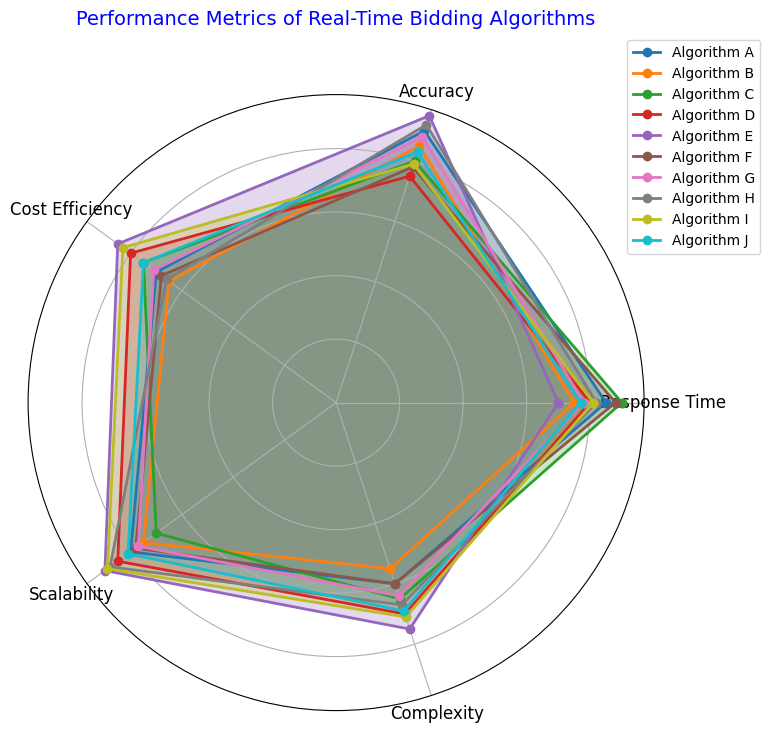Which algorithm has the highest accuracy? From the radar chart, locate the point on the 'Accuracy' axis that reaches the furthest out. Algorithm E peaks at the 95 mark, which is the highest value for accuracy.
Answer: Algorithm E Which algorithm shows the best cost efficiency and what is its value? On the 'Cost Efficiency' axis, the point that is furthest from the center represents the best cost efficiency. Algorithm E has the highest cost-efficiency value of 85.
Answer: Algorithm E, 85 Between Algorithm A and Algorithm D, which has better scalability? Compare the length of the lines from the center to the points on the 'Scalability' axis for both Algorithm A and Algorithm D. The point for Algorithm D is further out, indicating better scalability.
Answer: Algorithm D Which algorithm has the lowest complexity? Identify the algorithm whose line on the 'Complexity' axis is the closest to the center. Algorithm B has the lowest complexity value at 55.
Answer: Algorithm B What is the average response time of Algorithms A, B, and C? First, locate the response time values for Algorithms A, B, and C: 85, 75, 90. Calculate the average: (85 + 75 + 90) / 3.
Answer: 83.33 How does Algorithm H's performance in complexity compare to Algorithm J's? Look at the positions on the 'Complexity' axis for both Algorithm H and Algorithm J. The point for Algorithm H is slightly closer to the center than for Algorithm J, indicating that Algorithm H has a lower complexity.
Answer: Algorithm H Which two algorithms have the most similar scalability scores? Observe the distances of each algorithm's point on the 'Scalability' axis. Algorithms G and J both have scores that are very close to each other, around the 77-81 range.
Answer: Algorithms G and J What is the combined accuracy score for Algorithms E and H? Look at the accuracy values for Algorithms E and H: 95 and 92. Add them together: 95 + 92.
Answer: 187 Between Algorithm C and Algorithm F, which one is more cost-efficient and by how much? Compare the values on the 'Cost Efficiency' axis for Algorithm C and Algorithm F. Algorithm C has a cost efficiency of 75 and Algorithm F has 68. Calculate the difference: 75 - 68.
Answer: Algorithm C, 7 Which algorithm has the highest overall performance when considering accuracy and complexity together? Consider both 'Accuracy' and 'Complexity' axes. Algorithms E and H have the highest accuracy values, but Algorithm H has a lower complexity than Algorithm E, making Algorithm H better overall when considering both metrics.
Answer: Algorithm H 